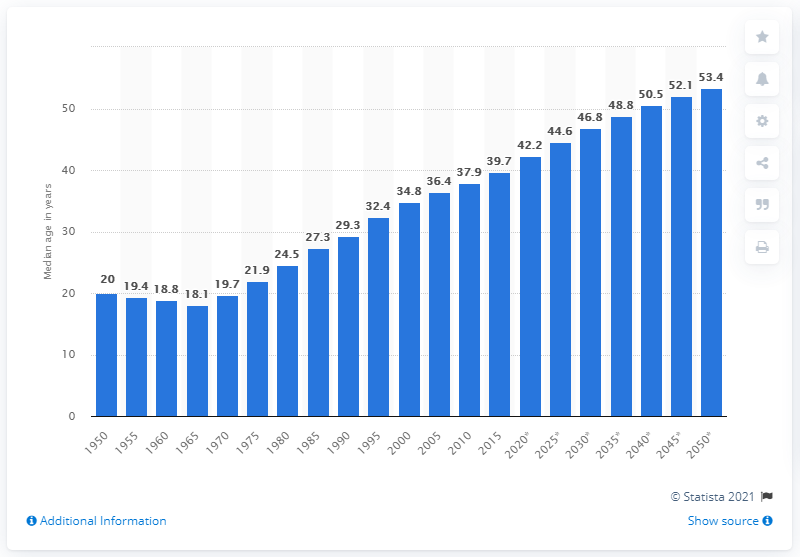Outline some significant characteristics in this image. Since 1965, the median age of the Singapore population has been increasing. 